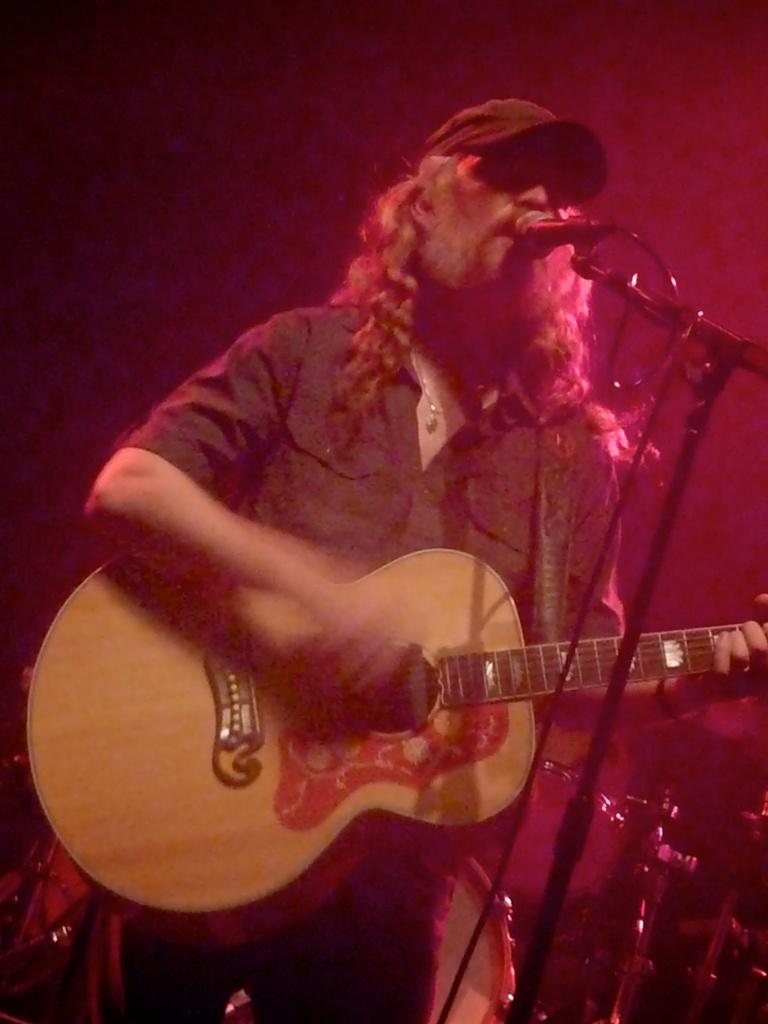What is the man in the image doing? The man is playing a guitar and singing. How is the man amplifying his voice in the image? The man is using a microphone. What song is the man singing in the image? There is no specific song mentioned in the image, so we cannot determine which song the man is singing. 